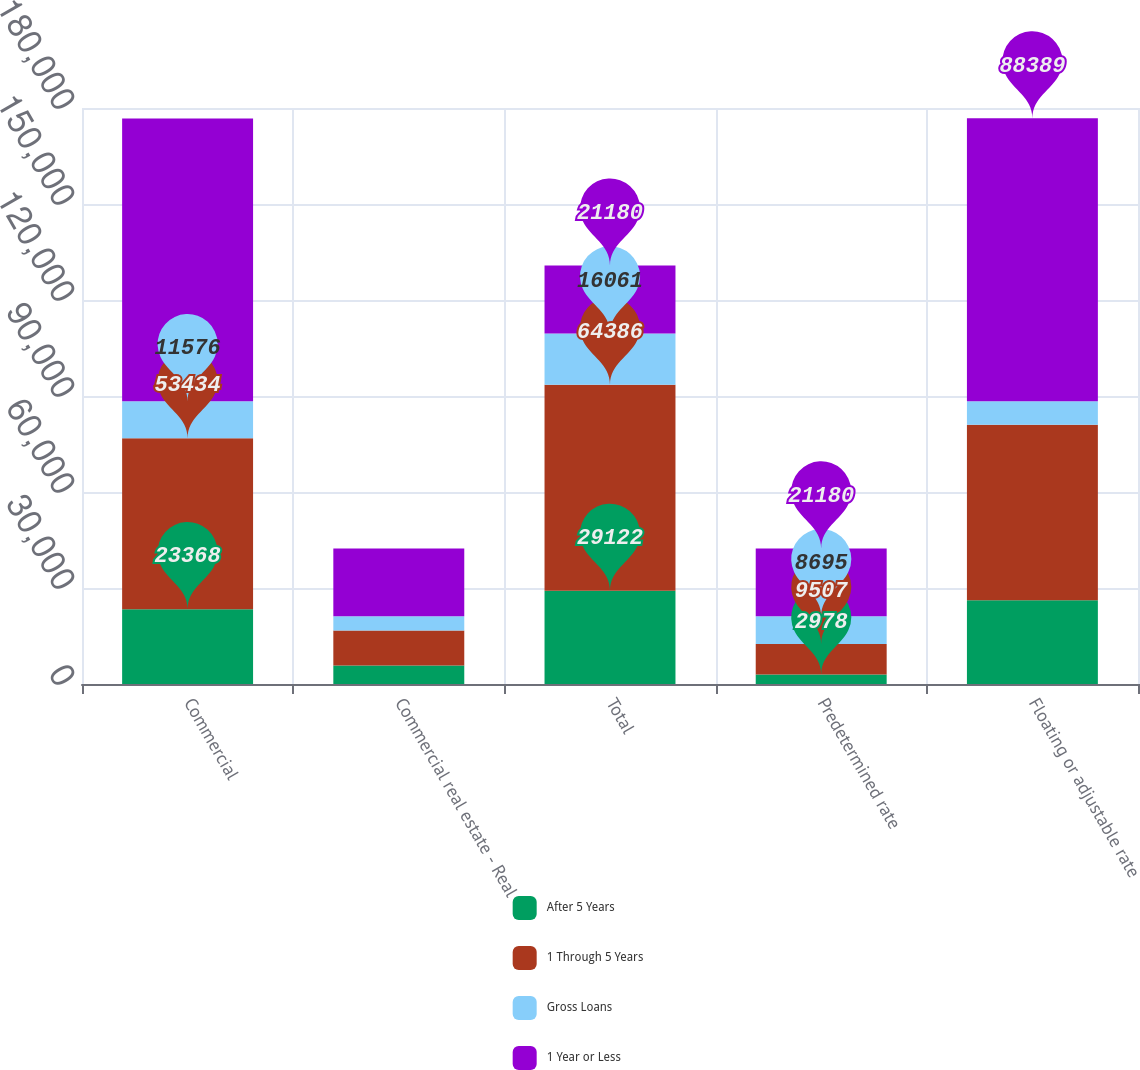Convert chart. <chart><loc_0><loc_0><loc_500><loc_500><stacked_bar_chart><ecel><fcel>Commercial<fcel>Commercial real estate - Real<fcel>Total<fcel>Predetermined rate<fcel>Floating or adjustable rate<nl><fcel>After 5 Years<fcel>23368<fcel>5754<fcel>29122<fcel>2978<fcel>26144<nl><fcel>1 Through 5 Years<fcel>53434<fcel>10952<fcel>64386<fcel>9507<fcel>54879<nl><fcel>Gross Loans<fcel>11576<fcel>4485<fcel>16061<fcel>8695<fcel>7366<nl><fcel>1 Year or Less<fcel>88378<fcel>21191<fcel>21180<fcel>21180<fcel>88389<nl></chart> 